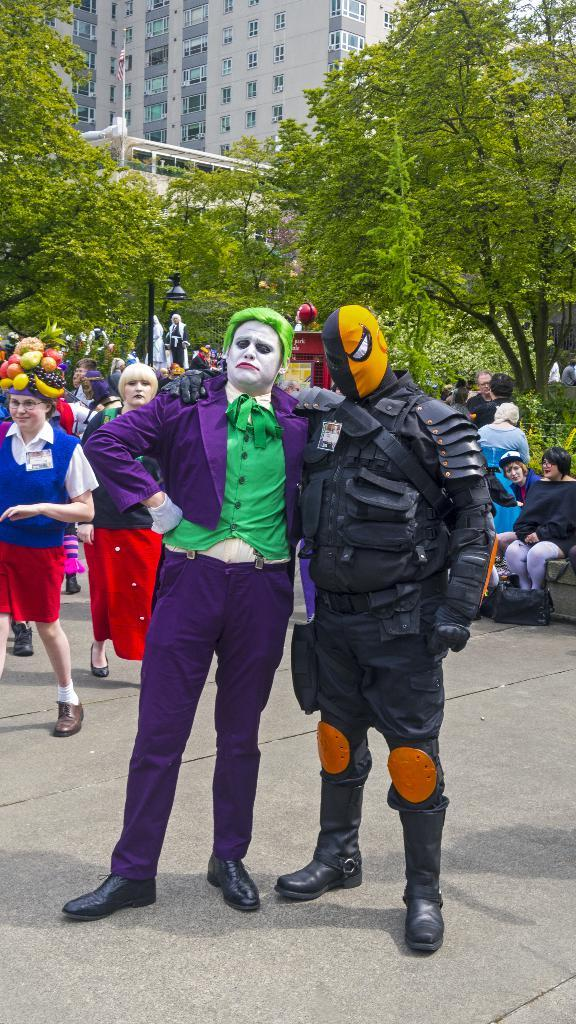How many people are in the image? There are people in the image, but the exact number is not specified. What are some of the people wearing? Some of the people are wearing costumes. What type of structure is visible in the image? There is a building in the image. What architectural feature can be seen in the image? There are windows in the image. What is the tall, vertical object in the image? There is a light pole in the image. What is the cloth object with a design or symbol attached to a pole? There is a flag in the image. What type of natural vegetation is present in the image? There are trees in the image. What type of smaller, non-woody plants are present in the image? There are plants in the image. How many horses are present in the image? There are no horses mentioned or visible in the image. What type of conversation are the people having in the image? The facts provided do not give any information about the people talking or the content of their conversation. 